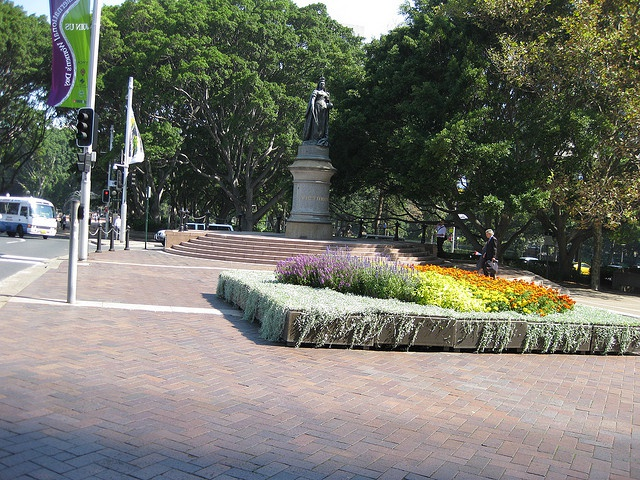Describe the objects in this image and their specific colors. I can see bus in gray, white, darkgray, navy, and black tones, traffic light in gray, black, darkgray, and white tones, people in gray, black, and lightgray tones, truck in gray, black, white, and navy tones, and people in gray and black tones in this image. 